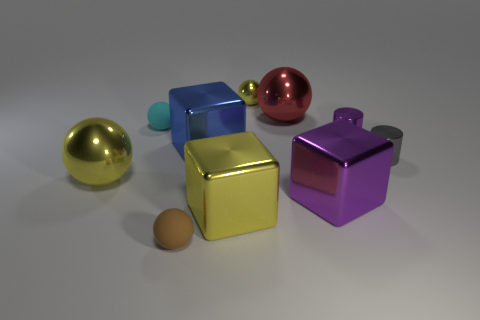Subtract all brown balls. How many balls are left? 4 Subtract all tiny cyan matte balls. How many balls are left? 4 Subtract 2 balls. How many balls are left? 3 Subtract all gray balls. Subtract all green blocks. How many balls are left? 5 Subtract all blocks. How many objects are left? 7 Add 7 purple cubes. How many purple cubes exist? 8 Subtract 0 yellow cylinders. How many objects are left? 10 Subtract all small cyan rubber balls. Subtract all brown shiny things. How many objects are left? 9 Add 2 small purple metal objects. How many small purple metal objects are left? 3 